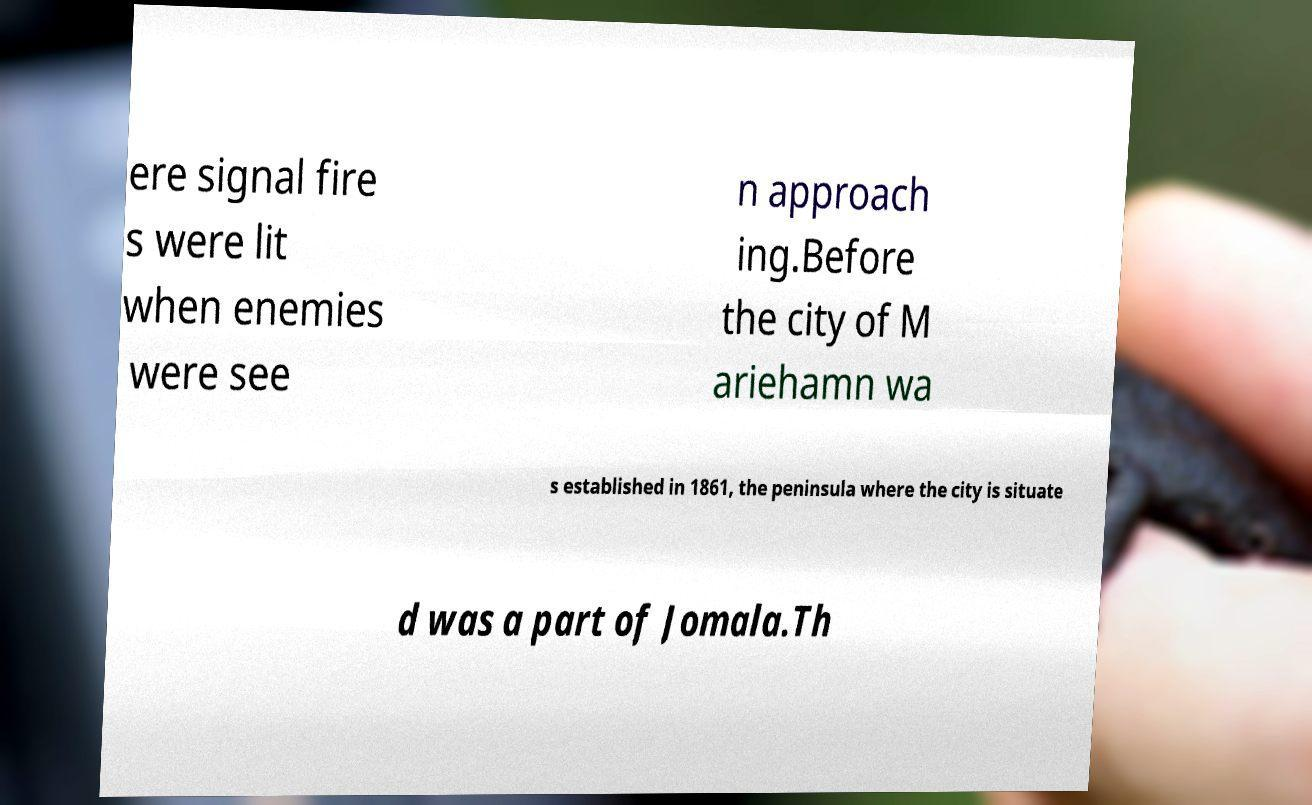There's text embedded in this image that I need extracted. Can you transcribe it verbatim? ere signal fire s were lit when enemies were see n approach ing.Before the city of M ariehamn wa s established in 1861, the peninsula where the city is situate d was a part of Jomala.Th 